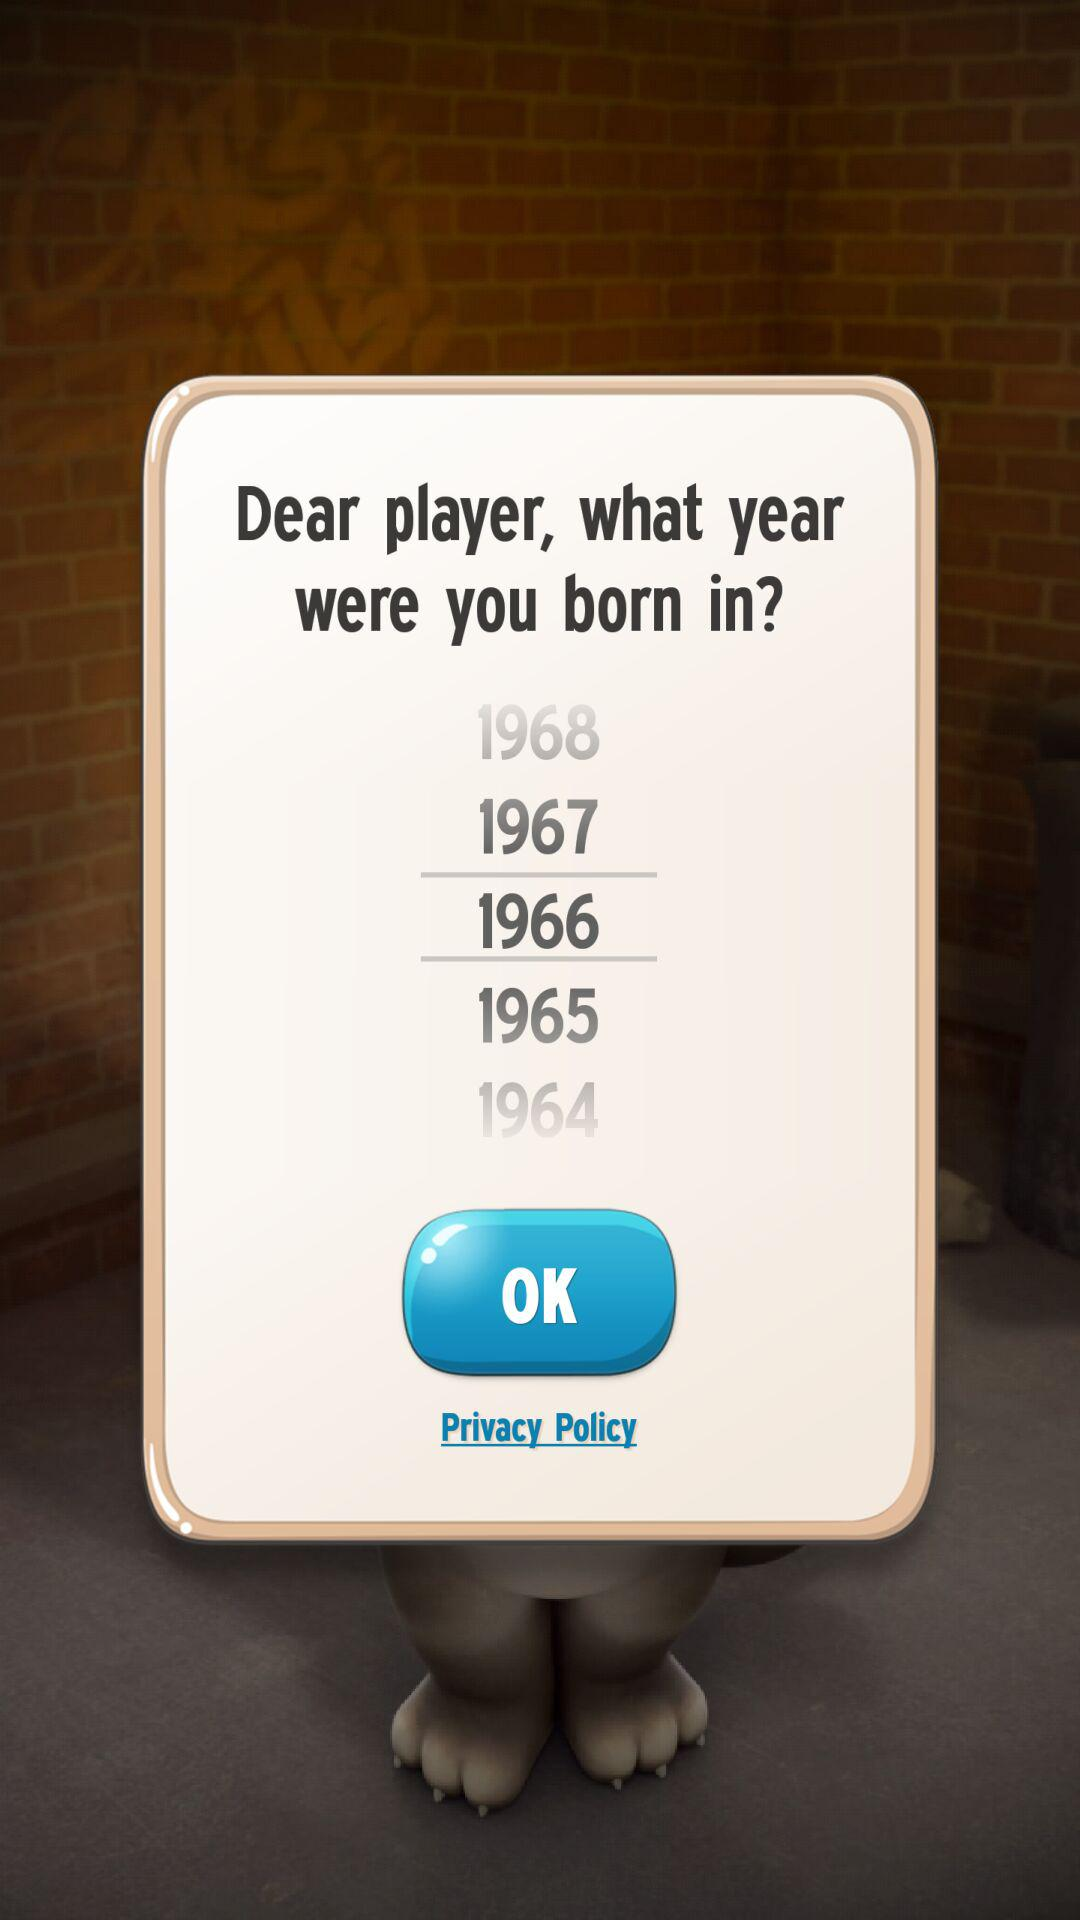Which year is selected as birth year? The year is selected as birth year is 1966. 